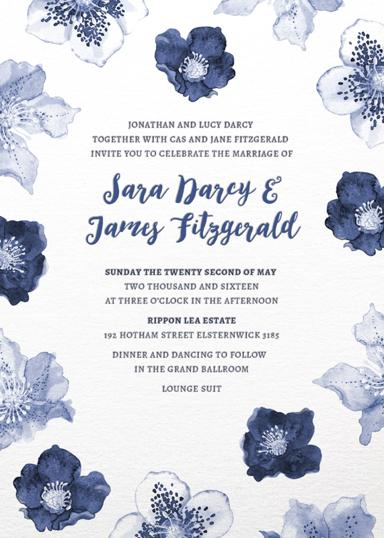Who are the parents of the bride and groom? The bride and groom, Sara and James, are proudly introduced by their parents: Jonathan and Lucy Darcy, along with Cas and Jane Fitzgerald, who have been pivotal in their journey towards this joyful day. 